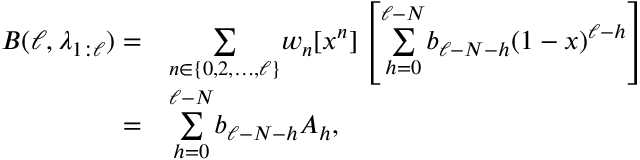<formula> <loc_0><loc_0><loc_500><loc_500>\begin{array} { r l } { B ( \ell , \lambda _ { 1 \colon \ell } ) = } & { \underset { n \in \{ 0 , 2 , \dots , \ell \} } { \sum } w _ { n } [ x ^ { n } ] \left [ \overset { \ell - N } { \underset { h = 0 } { \sum } } b _ { \ell - N - h } ( 1 - x ) ^ { \ell - h } \right ] } \\ { = } & { \overset { \ell - N } { \underset { h = 0 } { \sum } } b _ { \ell - N - h } A _ { h } , } \end{array}</formula> 